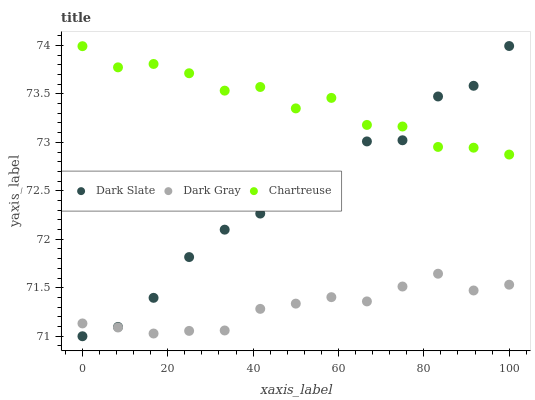Does Dark Gray have the minimum area under the curve?
Answer yes or no. Yes. Does Chartreuse have the maximum area under the curve?
Answer yes or no. Yes. Does Dark Slate have the minimum area under the curve?
Answer yes or no. No. Does Dark Slate have the maximum area under the curve?
Answer yes or no. No. Is Dark Gray the smoothest?
Answer yes or no. Yes. Is Dark Slate the roughest?
Answer yes or no. Yes. Is Chartreuse the smoothest?
Answer yes or no. No. Is Chartreuse the roughest?
Answer yes or no. No. Does Dark Slate have the lowest value?
Answer yes or no. Yes. Does Chartreuse have the lowest value?
Answer yes or no. No. Does Dark Slate have the highest value?
Answer yes or no. Yes. Does Chartreuse have the highest value?
Answer yes or no. No. Is Dark Gray less than Chartreuse?
Answer yes or no. Yes. Is Chartreuse greater than Dark Gray?
Answer yes or no. Yes. Does Dark Slate intersect Dark Gray?
Answer yes or no. Yes. Is Dark Slate less than Dark Gray?
Answer yes or no. No. Is Dark Slate greater than Dark Gray?
Answer yes or no. No. Does Dark Gray intersect Chartreuse?
Answer yes or no. No. 